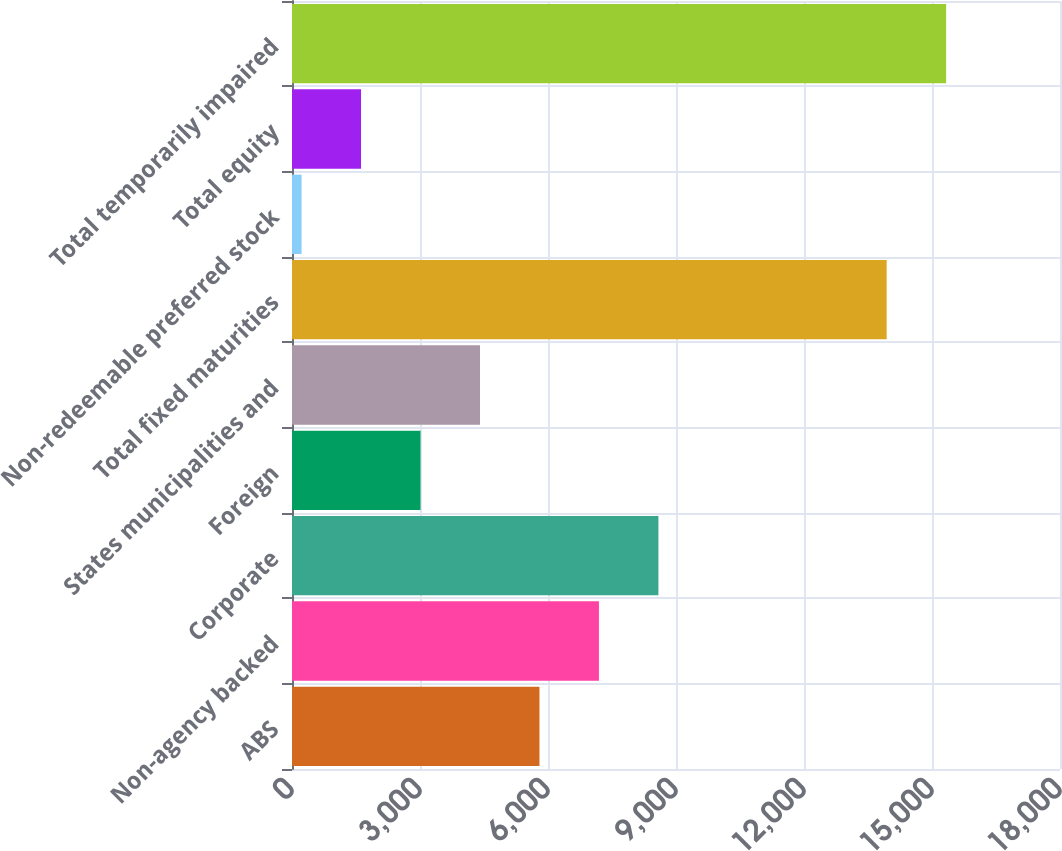Convert chart. <chart><loc_0><loc_0><loc_500><loc_500><bar_chart><fcel>ABS<fcel>Non-agency backed<fcel>Corporate<fcel>Foreign<fcel>States municipalities and<fcel>Total fixed maturities<fcel>Non-redeemable preferred stock<fcel>Total equity<fcel>Total temporarily impaired<nl><fcel>5800<fcel>7194<fcel>8588<fcel>3012<fcel>4406<fcel>13937<fcel>224<fcel>1618<fcel>15331<nl></chart> 